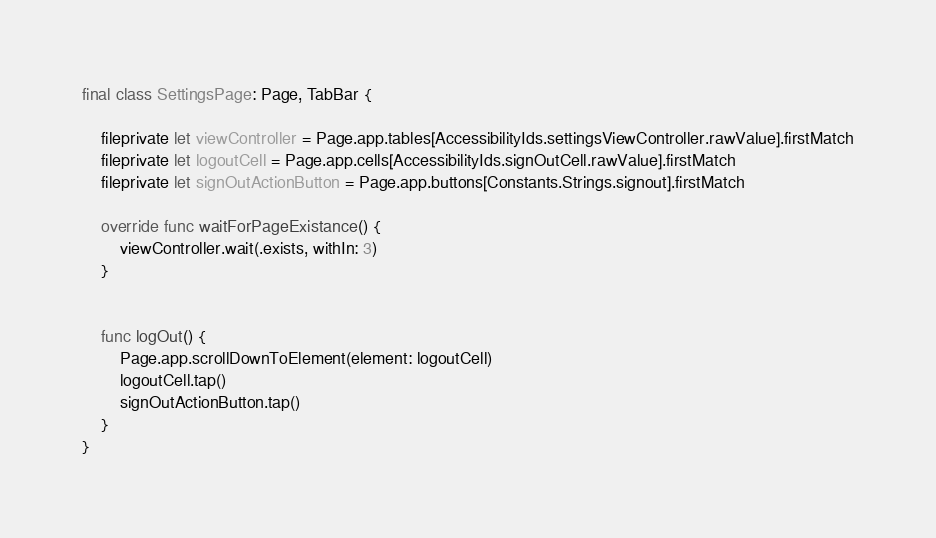Convert code to text. <code><loc_0><loc_0><loc_500><loc_500><_Swift_>final class SettingsPage: Page, TabBar {
    
    fileprivate let viewController = Page.app.tables[AccessibilityIds.settingsViewController.rawValue].firstMatch
    fileprivate let logoutCell = Page.app.cells[AccessibilityIds.signOutCell.rawValue].firstMatch
    fileprivate let signOutActionButton = Page.app.buttons[Constants.Strings.signout].firstMatch
    
    override func waitForPageExistance() {
        viewController.wait(.exists, withIn: 3)
    }
    
    
    func logOut() {
        Page.app.scrollDownToElement(element: logoutCell)
        logoutCell.tap()
        signOutActionButton.tap()
    }
}
</code> 